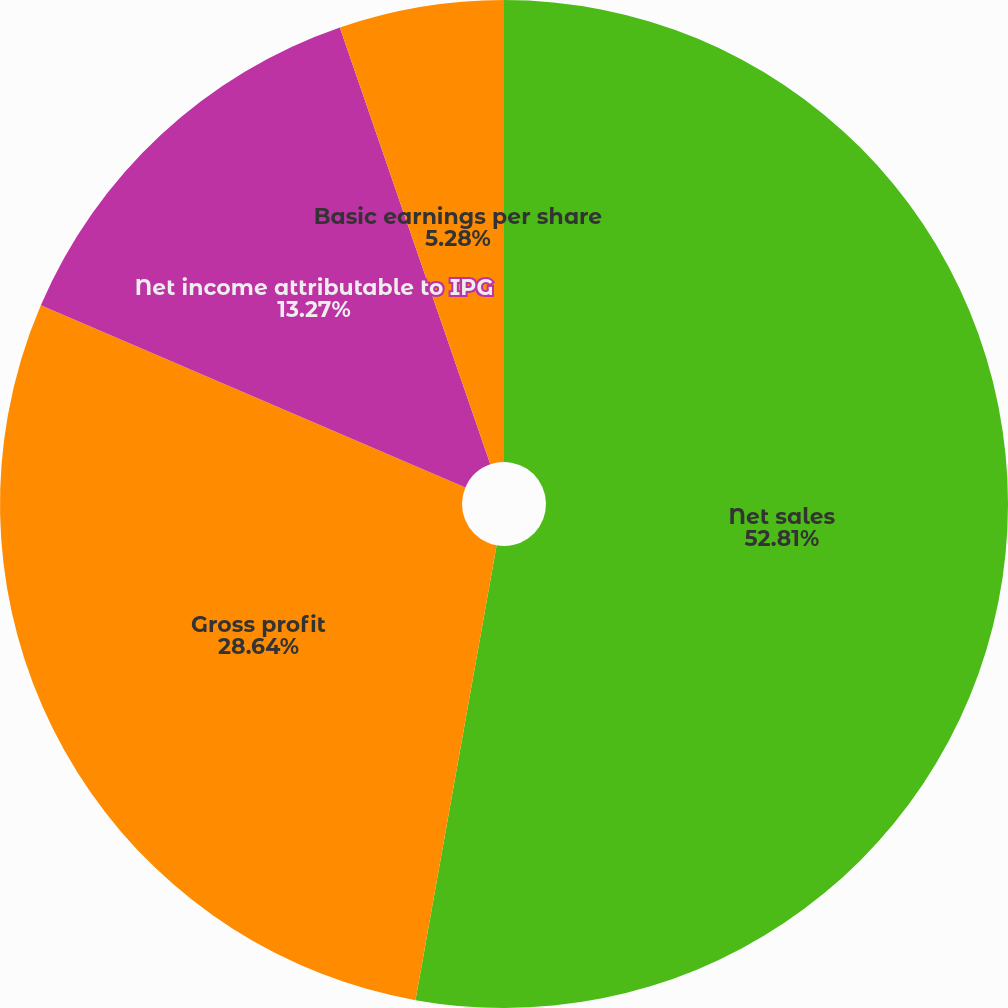<chart> <loc_0><loc_0><loc_500><loc_500><pie_chart><fcel>Net sales<fcel>Gross profit<fcel>Net income attributable to IPG<fcel>Basic earnings per share<fcel>Diluted earnings per share<nl><fcel>52.81%<fcel>28.64%<fcel>13.27%<fcel>5.28%<fcel>0.0%<nl></chart> 